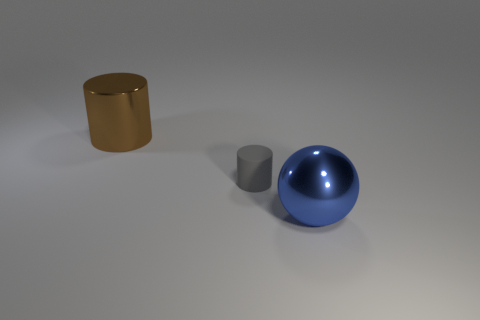Is there anything else that has the same material as the gray thing?
Your response must be concise. No. How many objects are in front of the large cylinder and behind the big blue shiny ball?
Your answer should be very brief. 1. Are there any other things that have the same size as the matte thing?
Make the answer very short. No. Is the number of large cylinders on the left side of the matte cylinder greater than the number of big blue things behind the metallic ball?
Your answer should be very brief. Yes. There is a big object on the right side of the matte cylinder; what material is it?
Offer a very short reply. Metal. There is a large brown object; is it the same shape as the rubber object that is to the left of the blue ball?
Your response must be concise. Yes. How many gray matte things are in front of the large metallic object behind the thing in front of the matte cylinder?
Your answer should be compact. 1. What is the color of the other large thing that is the same shape as the gray rubber thing?
Your answer should be very brief. Brown. Is there anything else that is the same shape as the blue object?
Your answer should be very brief. No. What number of spheres are small yellow metal things or large brown things?
Offer a terse response. 0. 